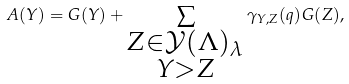Convert formula to latex. <formula><loc_0><loc_0><loc_500><loc_500>A ( Y ) = G ( Y ) + \sum _ { \substack { Z \in { \mathcal { Y } } ( \Lambda ) _ { \lambda } \\ Y > Z } } \gamma _ { Y , Z } ( q ) G ( Z ) ,</formula> 